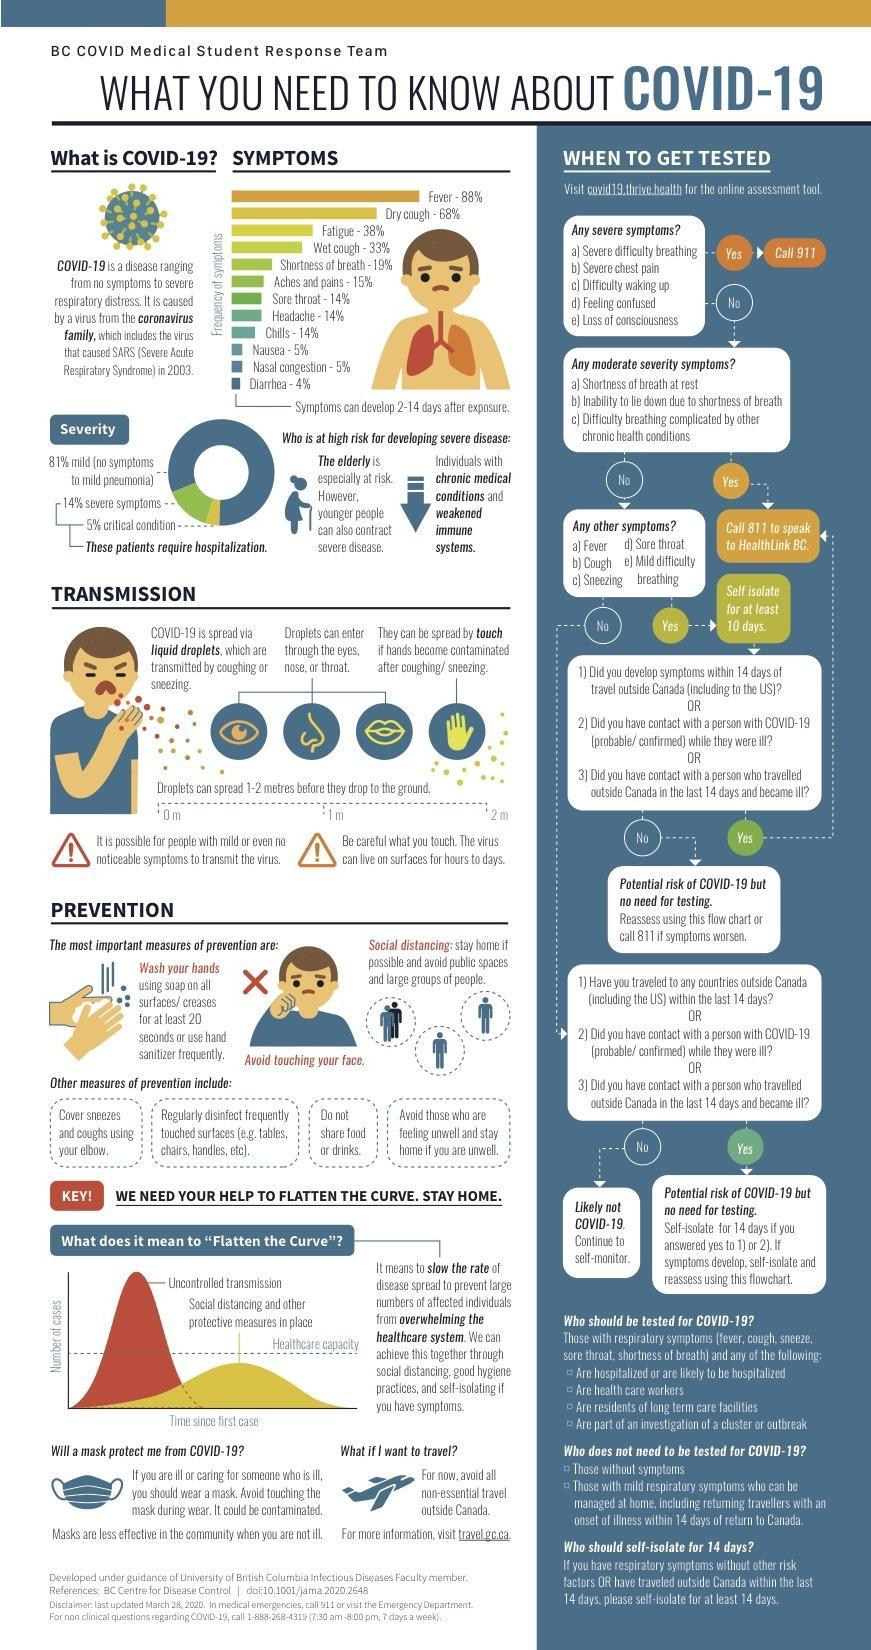On what phone number should you call, in case you have a 'moderate severity symptom'?
Answer the question with a short phrase. 811 How many bullet points are mentioned under 'who should be tested for covid-19'? 4 How many 'severe symptoms' are mentioned here? 5 How many methods for prevention are mentioned here (including other measures)? 7 What should you do if you have 'shortness of breath at rest'? Call 811 to speak to Healthlink BC What should you do if you just have sneezing and sore throat? Self isolate for at least 10 days What should you do if you have only 'mild difficulty breathing'? Self isolate for at least 10 days What are the three most important measures of 'prevention'? Wash your hands, avoid touching your face, social distancing Which are the first three mentioned under 'other symptoms'? Fever, cough, sneezing How many 'other symptoms' are mentioned? 5 On what phone number should you call, in case you have a severe symptom? 911 What should you do if you are unable to lie down due to shortness of breath? Call 811 to speak to Healthlink BC What should you do, if you have difficulty waking up? Call 911 What percentage of covid-19 patients require hospitalization? 5% What is the term used for  - ' to slow the rate of disease spread to prevent overwhelming the health care system'? Flatten the curve Name two diseases caused by a virus from the coronavirus family? Covid-19, SARS What should you do if you have 'severe chest pain'? Call 911 Through where can the infected droplets enter the human body? Eyes, nose, or throat Which are the symptoms that have a 14% frequency? Sore throat, headache, chills How many 'moderate severity' symptoms are mentioned 3 